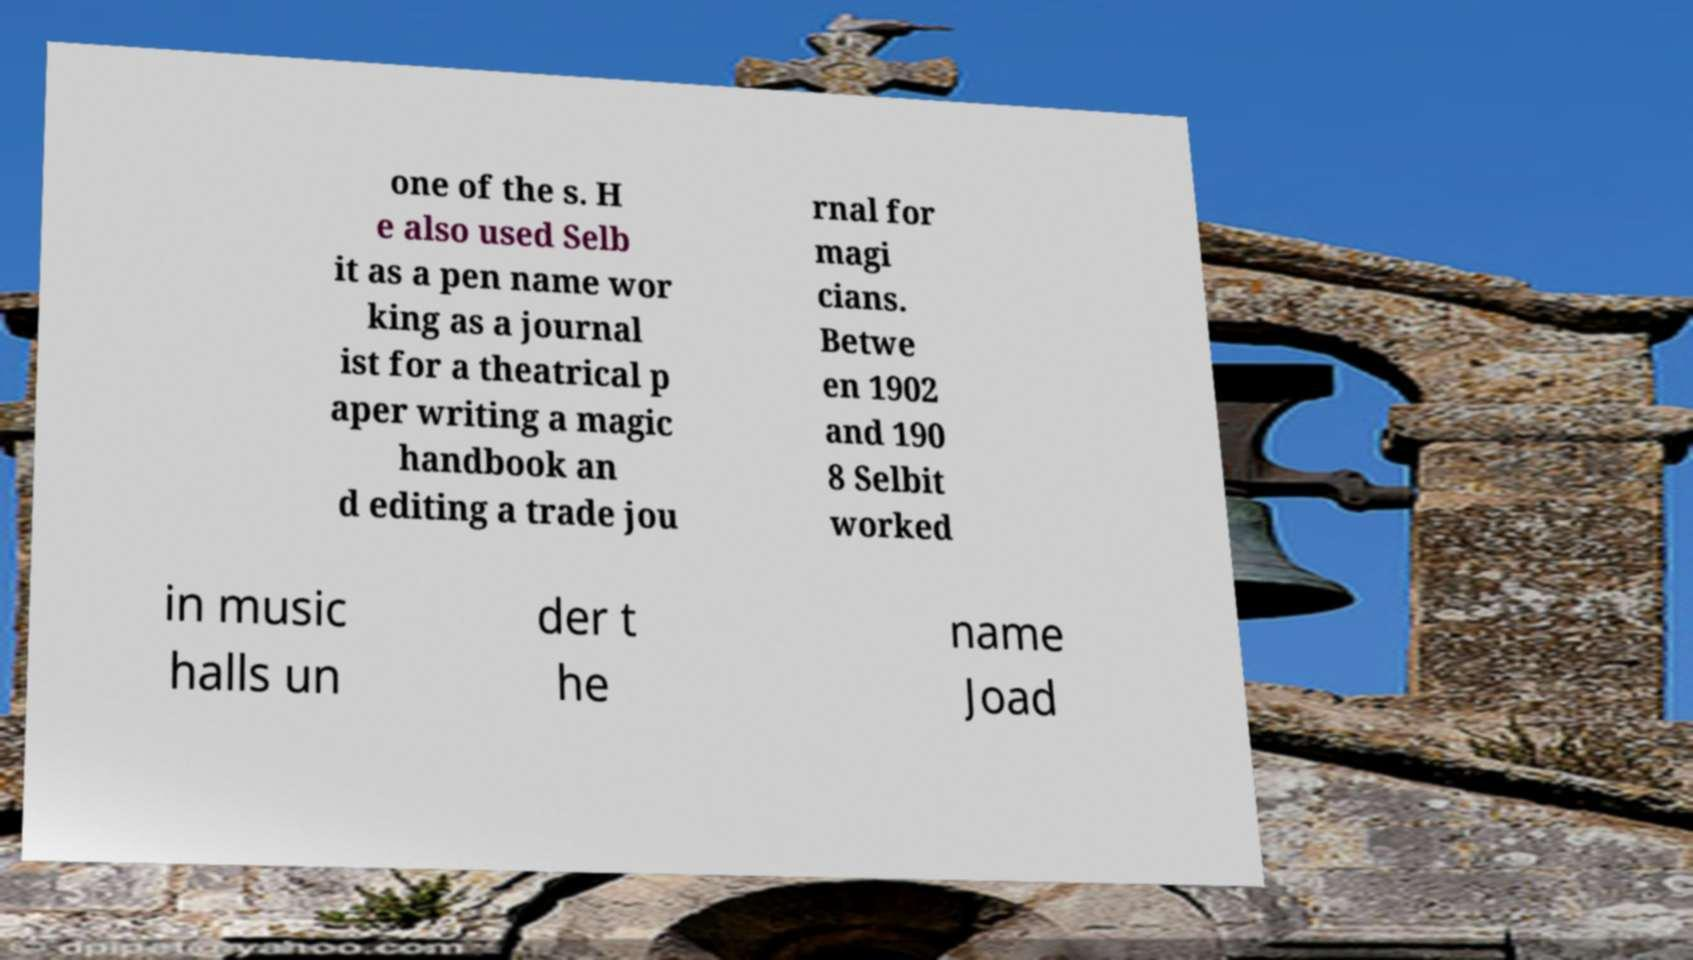I need the written content from this picture converted into text. Can you do that? one of the s. H e also used Selb it as a pen name wor king as a journal ist for a theatrical p aper writing a magic handbook an d editing a trade jou rnal for magi cians. Betwe en 1902 and 190 8 Selbit worked in music halls un der t he name Joad 